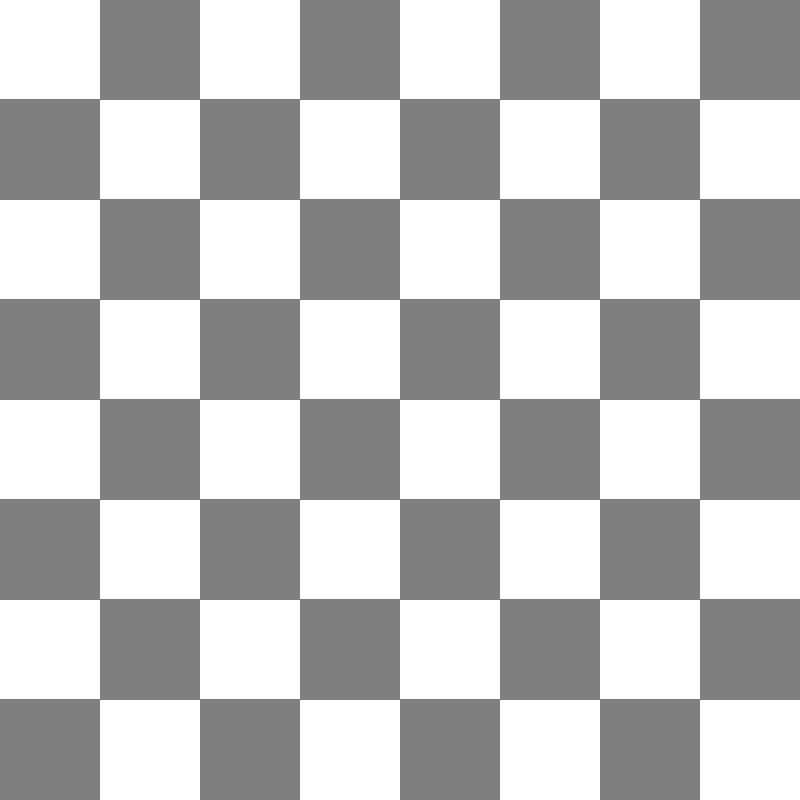In a physics experiment conducted at the University of Panama, a laser beam is directed through a chessboard-shaped diffraction grating. The grating consists of 8x8 alternating transparent and opaque squares, similar to a chessboard pattern. If the wavelength of the laser is 650 nm and the width of each square on the grating is 0.1 mm, what is the angular separation (in radians) between the central maximum and the first-order maximum in the resulting diffraction pattern? Let's approach this step-by-step:

1) The diffraction pattern from a chessboard grating is similar to that of a two-dimensional diffraction grating. The maxima occur where constructive interference happens.

2) For a two-dimensional grating, the condition for maxima is given by:

   $$\sin \theta = \frac{m\lambda}{d}$$

   Where:
   $\theta$ is the angle of diffraction
   $m$ is the order of diffraction (1 for first-order maximum)
   $\lambda$ is the wavelength of light
   $d$ is the spacing between slits (in this case, the width of two squares)

3) We're given:
   $\lambda = 650 \text{ nm} = 6.50 \times 10^{-7} \text{ m}$
   Width of each square = 0.1 mm = $1 \times 10^{-4} \text{ m}$

4) The spacing $d$ is twice the width of a single square:
   $d = 2 \times 1 \times 10^{-4} \text{ m} = 2 \times 10^{-4} \text{ m}$

5) For the first-order maximum, $m = 1$. Substituting into the equation:

   $$\sin \theta = \frac{1 \times 6.50 \times 10^{-7} \text{ m}}{2 \times 10^{-4} \text{ m}} = 3.25 \times 10^{-3}$$

6) We need to find $\theta$. For small angles, $\sin \theta \approx \theta$ (in radians). This approximation is valid here as the angle is small.

   Therefore, $\theta \approx 3.25 \times 10^{-3} \text{ radians}$

This is the angular separation between the central maximum and the first-order maximum.
Answer: $3.25 \times 10^{-3} \text{ radians}$ 